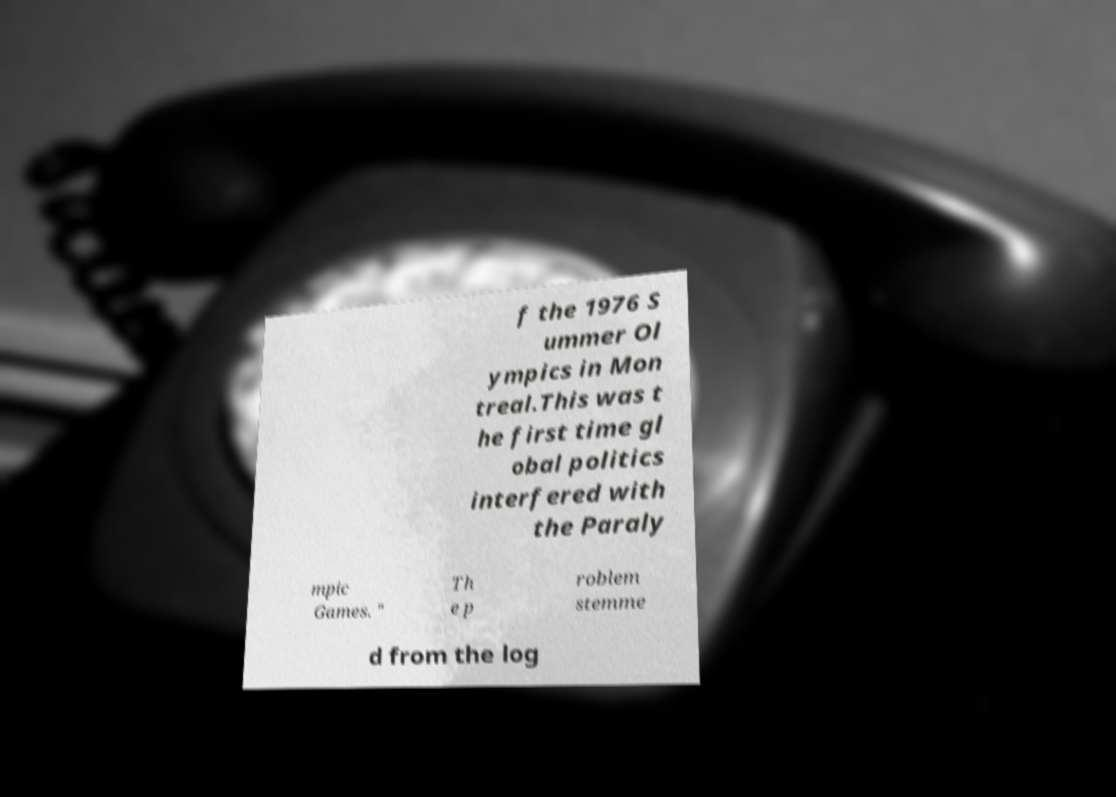There's text embedded in this image that I need extracted. Can you transcribe it verbatim? f the 1976 S ummer Ol ympics in Mon treal.This was t he first time gl obal politics interfered with the Paraly mpic Games. " Th e p roblem stemme d from the log 